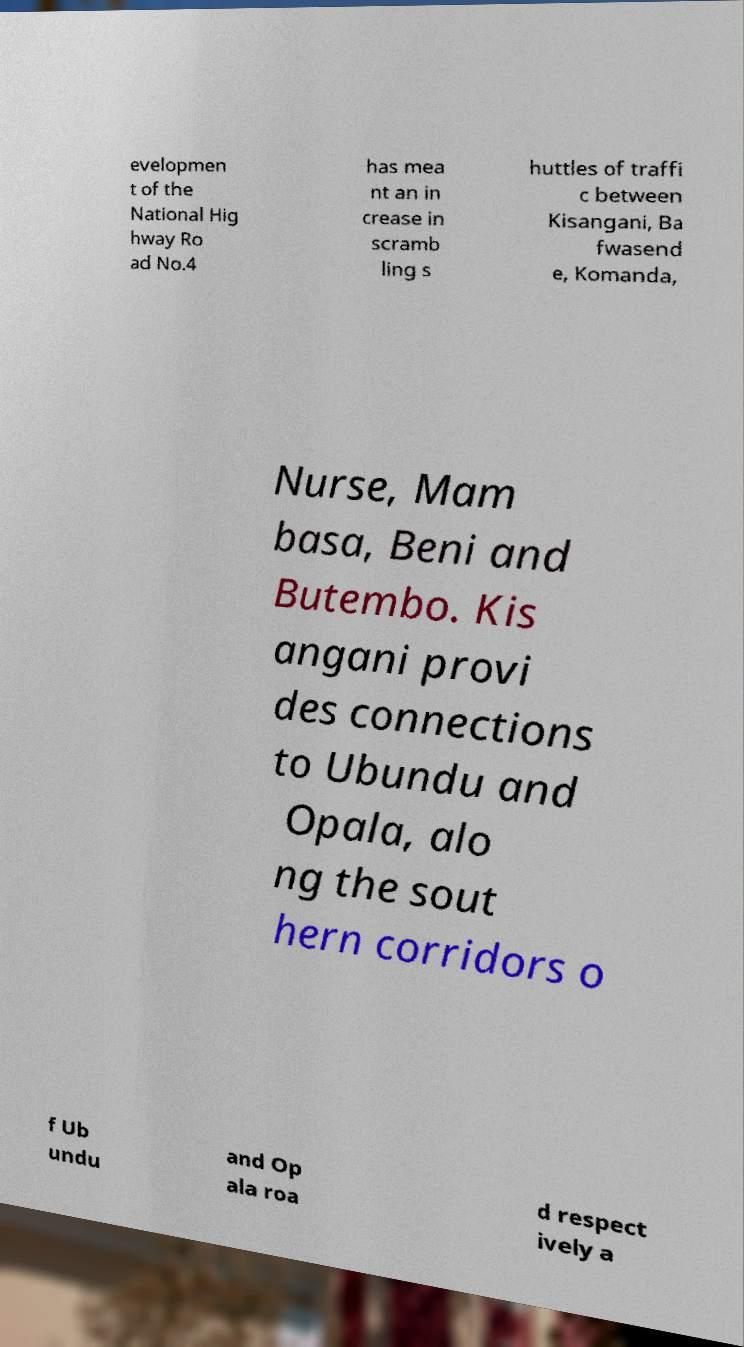Could you assist in decoding the text presented in this image and type it out clearly? evelopmen t of the National Hig hway Ro ad No.4 has mea nt an in crease in scramb ling s huttles of traffi c between Kisangani, Ba fwasend e, Komanda, Nurse, Mam basa, Beni and Butembo. Kis angani provi des connections to Ubundu and Opala, alo ng the sout hern corridors o f Ub undu and Op ala roa d respect ively a 